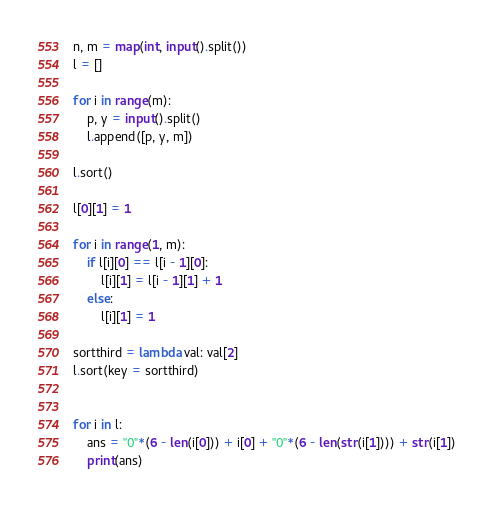Convert code to text. <code><loc_0><loc_0><loc_500><loc_500><_Python_>n, m = map(int, input().split())
l = []

for i in range(m):
    p, y = input().split()
    l.append([p, y, m])

l.sort()

l[0][1] = 1

for i in range(1, m):
    if l[i][0] == l[i - 1][0]:
        l[i][1] = l[i - 1][1] + 1
    else:
        l[i][1] = 1

sortthird = lambda val: val[2]
l.sort(key = sortthird)


for i in l:
    ans = "0"*(6 - len(i[0])) + i[0] + "0"*(6 - len(str(i[1]))) + str(i[1])
    print(ans)</code> 